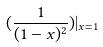Convert formula to latex. <formula><loc_0><loc_0><loc_500><loc_500>( \frac { 1 } { ( 1 - x ) ^ { 2 } } ) | _ { x = 1 }</formula> 